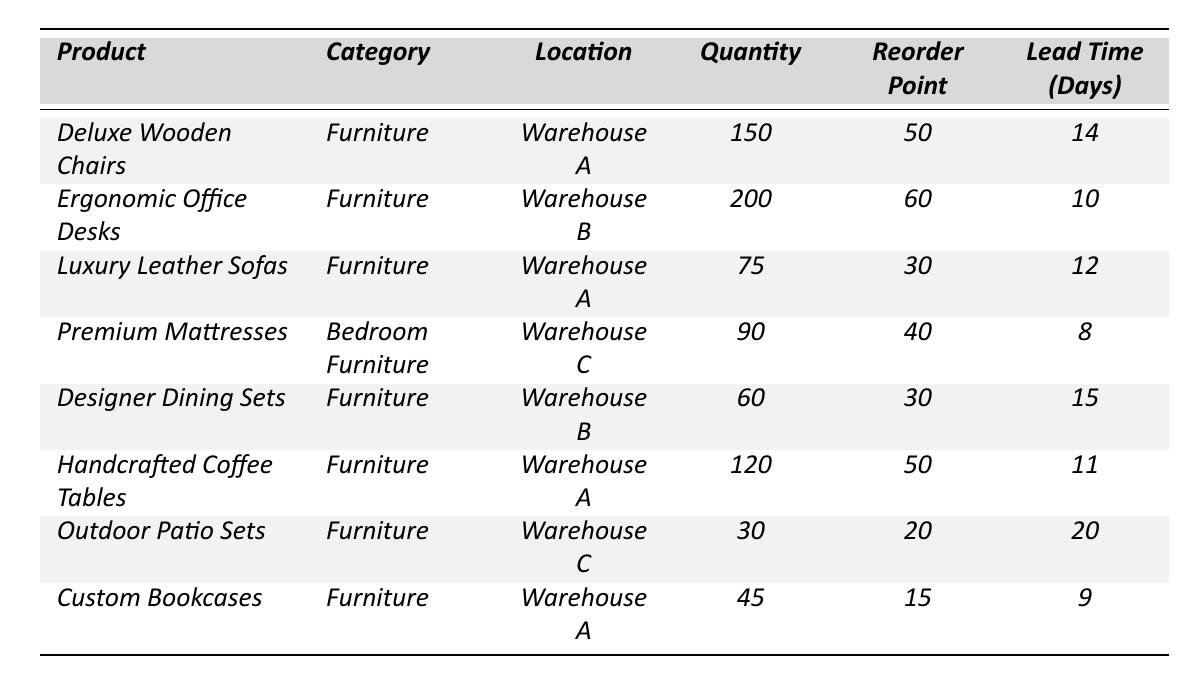What is the quantity of Deluxe Wooden Chairs in stock? The table shows that the QuantityInStock for Deluxe Wooden Chairs is listed as 150.
Answer: 150 How many Ergonomic Office Desks do we have and what is the Reorder Point? The table indicates that there are 200 Ergonomic Office Desks in stock, and the Reorder Point for this product is 60.
Answer: 200, 60 Is the stock for Luxury Leather Sofas below the Reorder Point? The QuantityInStock for Luxury Leather Sofas is 75, and the Reorder Point is 30. Since 75 is greater than 30, the stock is not below the Reorder Point.
Answer: No Which product has the longest lead time and what is that duration? By comparing the Lead Time (Days) values, Outdoor Patio Sets have the longest lead time of 20 days.
Answer: 20 days What is the total quantity of finished goods in Warehouse A? The total quantity of finished goods in Warehouse A can be calculated by adding the quantities: 150 (Deluxe Wooden Chairs) + 75 (Luxury Leather Sofas) + 120 (Handcrafted Coffee Tables) + 45 (Custom Bookcases) = 390.
Answer: 390 Which product has the highest Reorder Point? The Reorder Points are compared: 50 (Deluxe Wooden Chairs), 60 (Ergonomic Office Desks), 30 (Luxury Leather Sofas), 40 (Premium Mattresses), 30 (Designer Dining Sets), 50 (Handcrafted Coffee Tables), 20 (Outdoor Patio Sets), 15 (Custom Bookcases). The maximum is 60 for Ergonomic Office Desks.
Answer: Ergonomic Office Desks Are the Outdoor Patio Sets above or below their Reorder Point? Outdoor Patio Sets have a QuantityInStock of 30 and a Reorder Point of 20. Since 30 is above 20, we determine the stock is above the Reorder Point.
Answer: Above What percentage of the stock of Designer Dining Sets is currently available compared to its Reorder Point? To find the percentage, we can calculate (60 / 30) * 100 = 200%. This indicates that there are 200% of the Reorder Point available.
Answer: 200% If we combined all quantities in stock from Warehouse C, what would be the total? The total quantity in Warehouse C is calculated by adding: 90 (Premium Mattresses) + 30 (Outdoor Patio Sets) = 120.
Answer: 120 Which product has the lowest stock and how does it compare to its Reorder Point? The lowest stock is for Outdoor Patio Sets with a QuantityInStock of 30, which is above its Reorder Point of 20.
Answer: Lowest: Outdoor Patio Sets, Above Reorder Point 